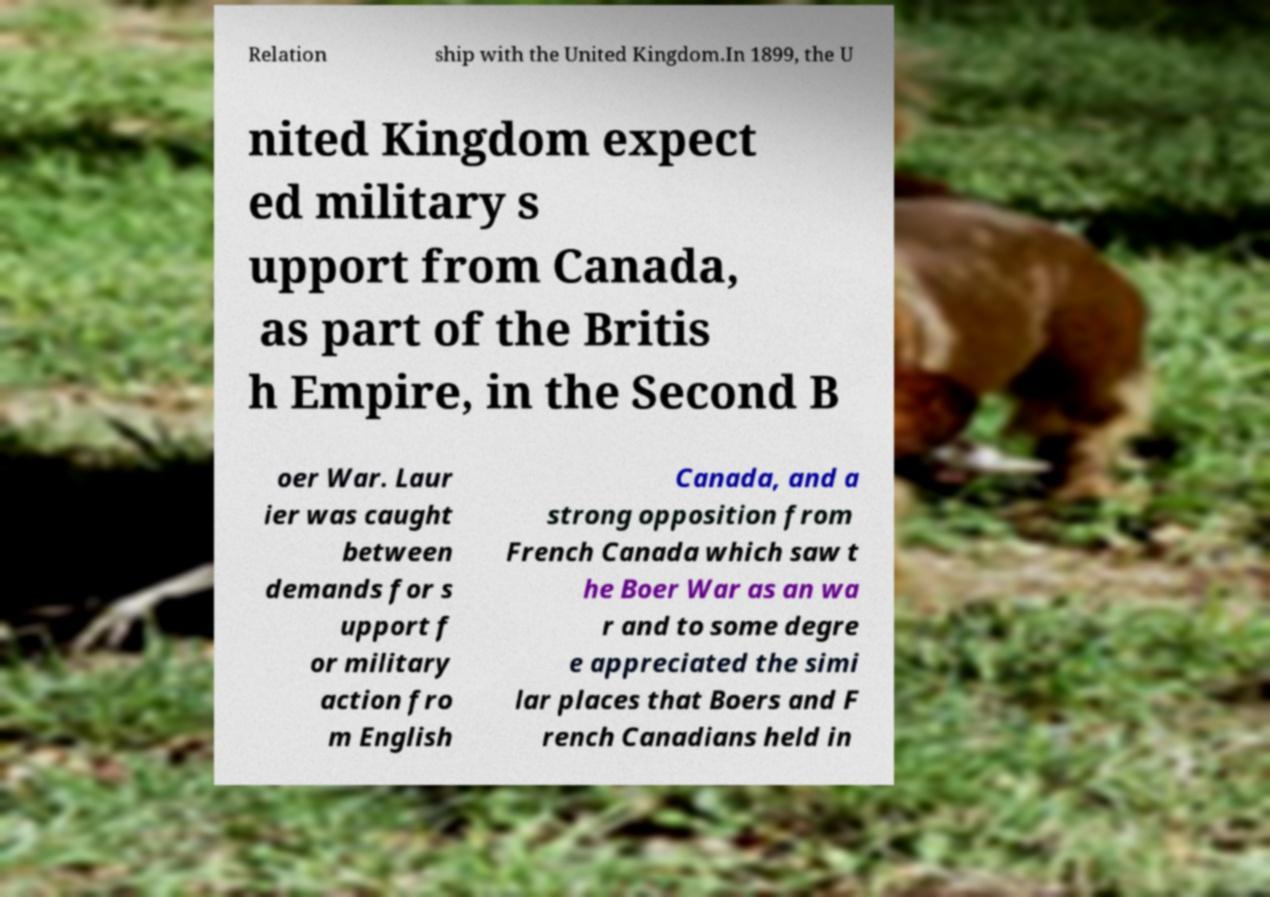Please identify and transcribe the text found in this image. Relation ship with the United Kingdom.In 1899, the U nited Kingdom expect ed military s upport from Canada, as part of the Britis h Empire, in the Second B oer War. Laur ier was caught between demands for s upport f or military action fro m English Canada, and a strong opposition from French Canada which saw t he Boer War as an wa r and to some degre e appreciated the simi lar places that Boers and F rench Canadians held in 